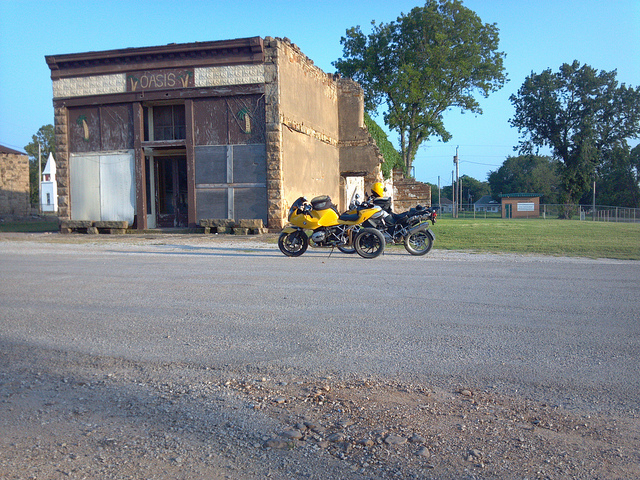Please transcribe the text information in this image. OASIS 